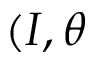Convert formula to latex. <formula><loc_0><loc_0><loc_500><loc_500>( I , \theta</formula> 